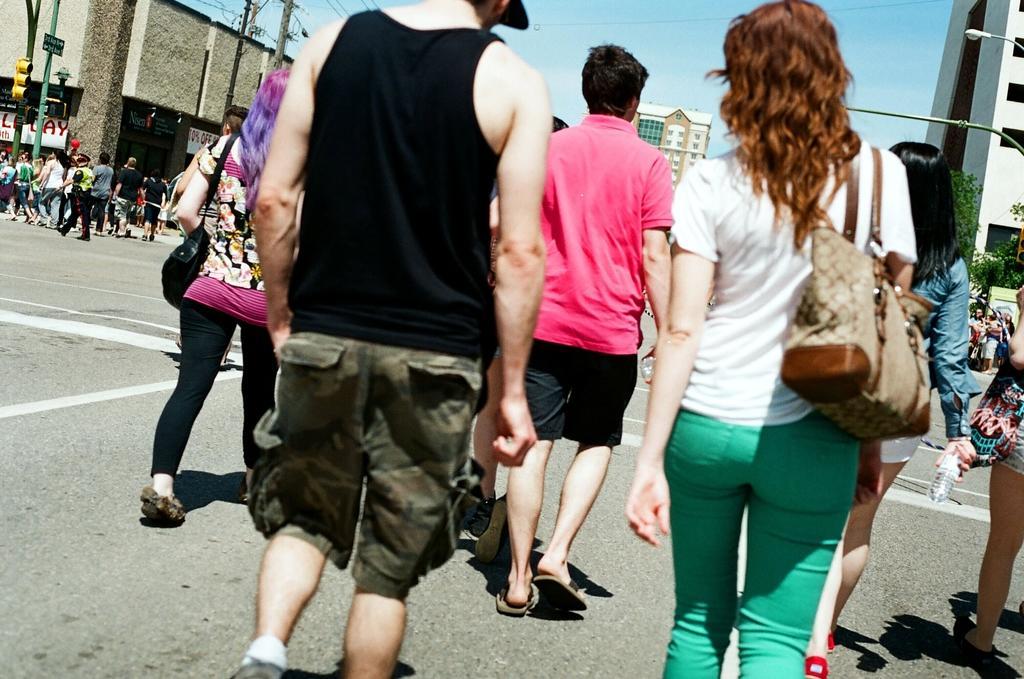Can you describe this image briefly? In this image I can see the group of people with different color dresses. I can see few people are with the bags. These people are on the road. To the side of the road I can see many poles and the boards. I can also see the trees and the buildings with windows. In the background I can see few more buildings and the sky. 